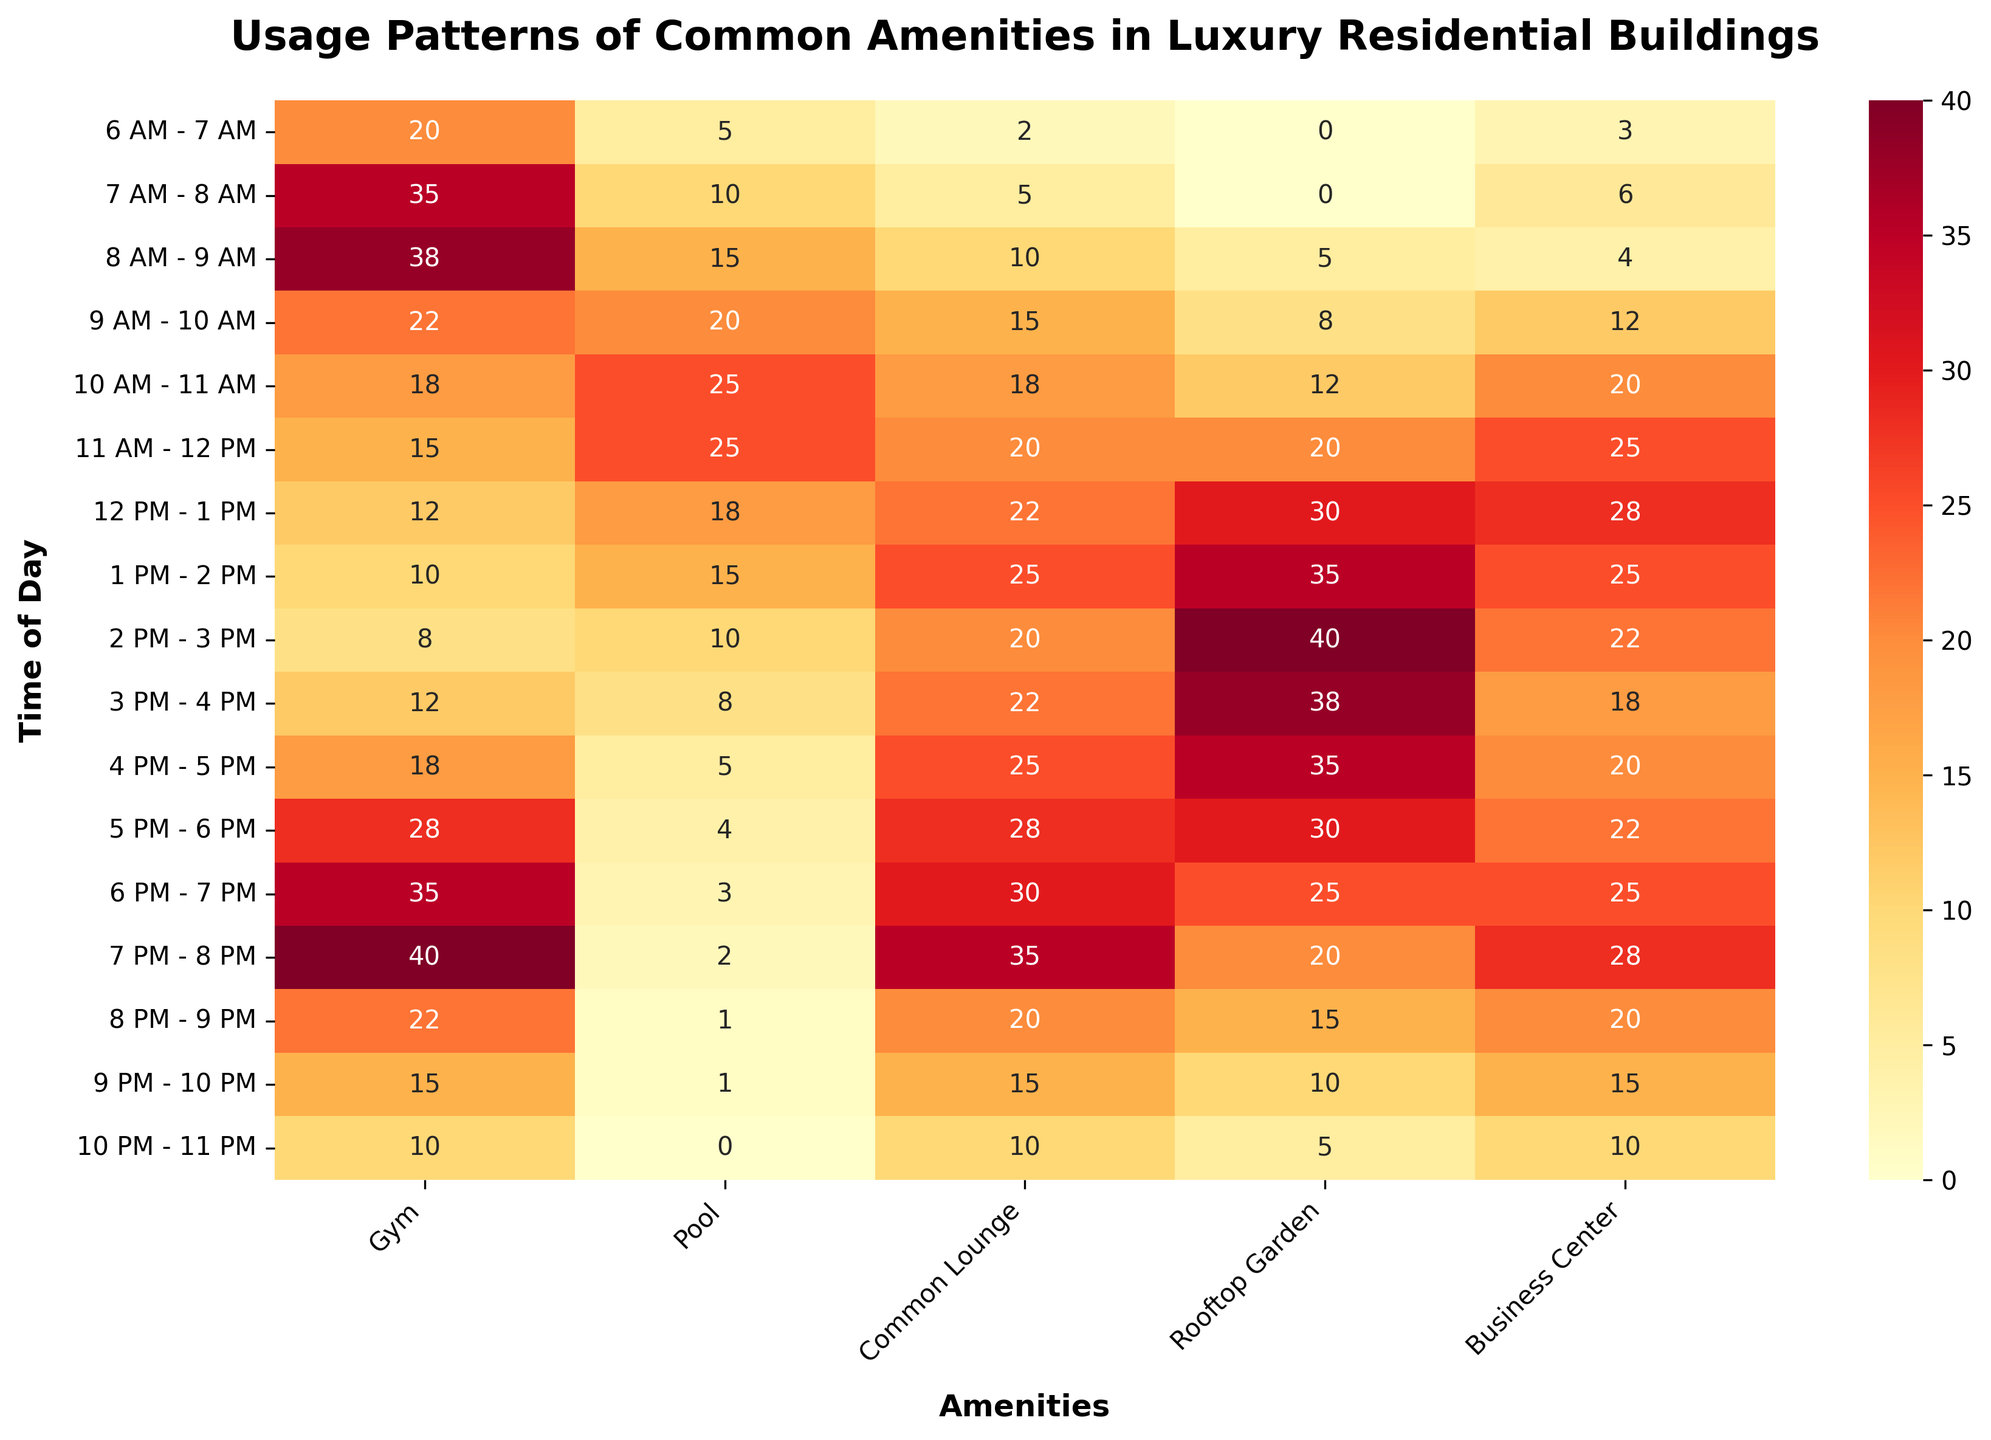What is the time slot with the highest gym usage? Look at the heatmap to find the time slot with the darkest shade corresponding to the gym. The darkest shade indicates the peak usage time. For the gym, the highest usage is seen from 7 PM to 8 PM with a value of 40.
Answer: 7 PM - 8 PM How many time slots have pool usage of 20 or more? Count the number of cells in the Pool column that have values equal to or greater than 20. These include the time slots 9 AM - 10 AM, 10 AM - 11 AM, 11 AM - 12 PM, and 12 PM - 1 PM (4 slots in total).
Answer: 4 Which amenity shows the least consistent usage throughout the day? This requires evaluating the variability of usage for each amenity. The Rooftop Garden shows significant variation (from 0 to 40), indicating inconsistent use compared to others.
Answer: Rooftop Garden During which time slot is the Business Center most used? Locate the highest value in the Business Center column. The highest value of 28 is found during the 12 PM - 1 PM and 7 PM - 8 PM time slots.
Answer: 12 PM - 1 PM, 7 PM - 8 PM What is the combined usage of the Common Lounge from 8 AM to 10 AM? Add the usage values for 8 AM - 9 AM and 9 AM - 10 AM in the Common Lounge column: 10 + 15 = 25.
Answer: 25 Which two amenities have the closest usage at 6 PM - 7 PM? Compare the values in the 6 PM - 7 PM row. The two nearest values are Common Lounge (30) and Rooftop Garden (25), with a difference of 5.
Answer: Common Lounge and Rooftop Garden During which time slot is the Business Center most used? Locate the highest value in the Business Center column. The highest value of 28 is found during the 12 PM - 1 PM and 7 PM - 8 PM time slots.
Answer: 12 PM - 1 PM, 7 PM - 8 PM How does pool usage change from 6 AM to 12 PM? Track the values in the Pool column from 6 AM to 12 PM. Starting at 5, the usage steadily increases to 0, indicating a morning rise followed by a consistent decline.
Answer: Increases Which amenity has the highest usage during the 1 PM - 2 PM time slot? Identify the maximum value in the 1 PM - 2 PM row across all amenities. The highest value of 35 corresponds to the Rooftop Garden.
Answer: Rooftop Garden In which time slot does the gym usage start to decline significantly? Look for when the values in the Gym column begin to decrease sharply. The drop starts after 7 PM - 8 PM (40), decreasing to 22 at 8 PM - 9 PM.
Answer: 8 PM - 9 PM 